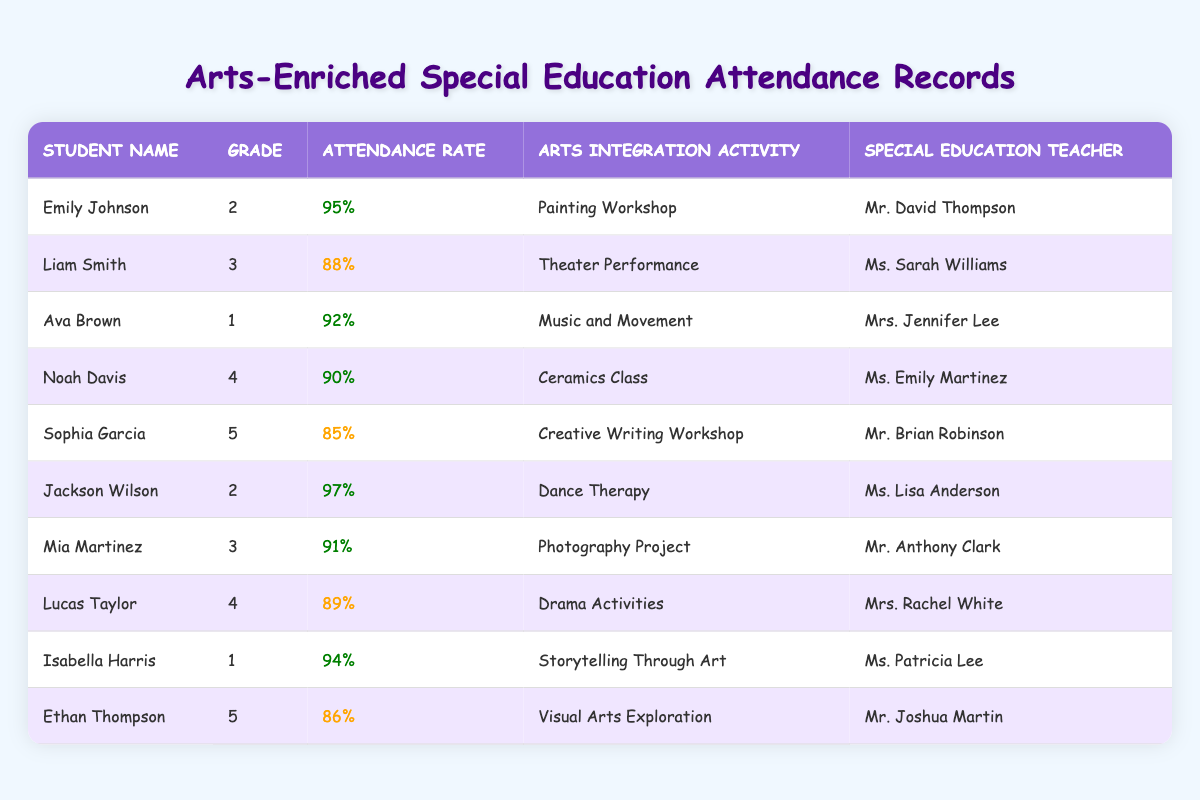What is the attendance rate of Jackson Wilson? Jackson Wilson's row shows an attendance rate of 97%.
Answer: 97% Who is the special education teacher for Emily Johnson? The table indicates that Emily Johnson is taught by Mr. David Thompson.
Answer: Mr. David Thompson What arts integration activity did Liam Smith participate in? Liam Smith's row lists "Theater Performance" as his arts integration activity.
Answer: Theater Performance Is Sophia Garcia's attendance rate higher than Ava Brown's? Sophia Garcia's attendance rate is 85%, while Ava Brown's is 92%. Therefore, Sophia's is not higher than Ava's.
Answer: No Which student has the highest attendance rate? The highest attendance rate listed is 97% for Jackson Wilson.
Answer: Jackson Wilson What is the average attendance rate of the students in grade 3? The attendance rates for grade 3 students (Liam Smith: 88%, Mia Martinez: 91%) sum to 179. Dividing by 2 gives an average attendance rate of 89.5%.
Answer: 89.5% How many students have an attendance rate of 90% or above? Count the students with rates 90% and above: Emily Johnson (95%), Jackson Wilson (97%), Ava Brown (92%), Noah Davis (90%), Mia Martinez (91%), Isabella Harris (94%). That totals to 6 students.
Answer: 6 Is there a student from grade 5 with an attendance rate below 87%? The attendance rates for grade 5 students are Sophia Garcia (85%) and Ethan Thompson (86%). Since Sophia has a rate below 87%, the answer is yes.
Answer: Yes Calculate the total attendance rate of students in grade 4. The attendance rates for grade 4 students are Noah Davis (90%) and Lucas Taylor (89%). Their total is 90 + 89 = 179.
Answer: 179 Which student in grade 1 has the highest attendance rate? The attendance rates for grade 1 are Ava Brown (92%) and Isabella Harris (94%). Isabella Harris has the higher rate of 94%.
Answer: Isabella Harris 